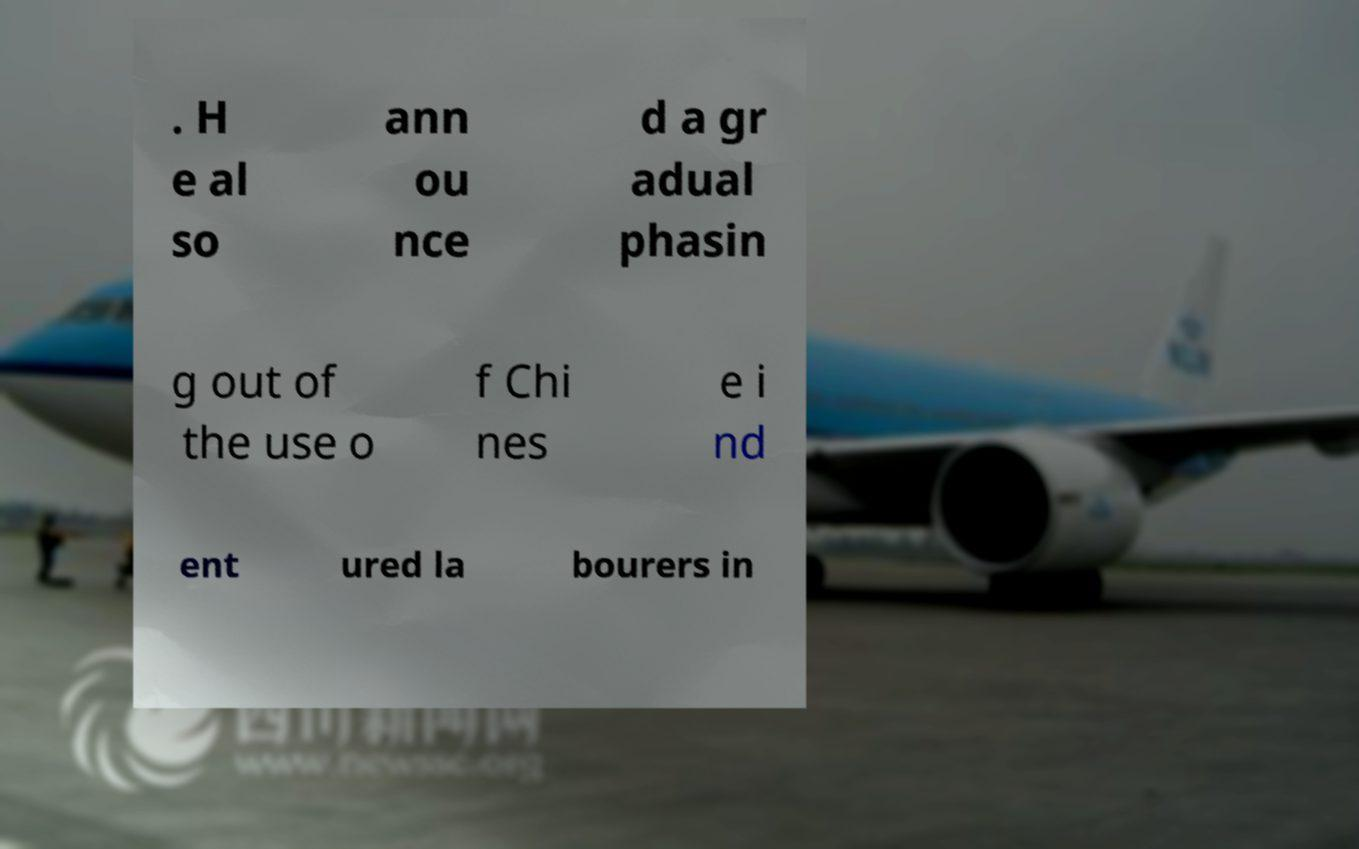Please read and relay the text visible in this image. What does it say? . H e al so ann ou nce d a gr adual phasin g out of the use o f Chi nes e i nd ent ured la bourers in 